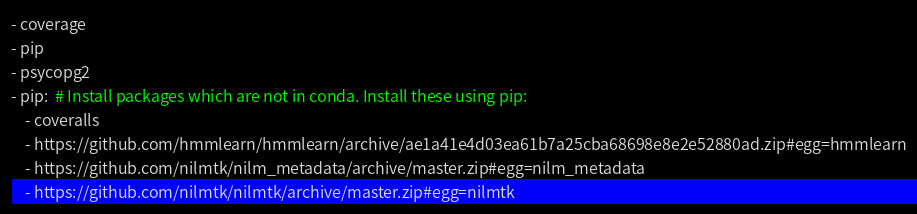<code> <loc_0><loc_0><loc_500><loc_500><_YAML_>- coverage
- pip
- psycopg2
- pip:  # Install packages which are not in conda. Install these using pip:
    - coveralls
    - https://github.com/hmmlearn/hmmlearn/archive/ae1a41e4d03ea61b7a25cba68698e8e2e52880ad.zip#egg=hmmlearn
    - https://github.com/nilmtk/nilm_metadata/archive/master.zip#egg=nilm_metadata
    - https://github.com/nilmtk/nilmtk/archive/master.zip#egg=nilmtk
</code> 